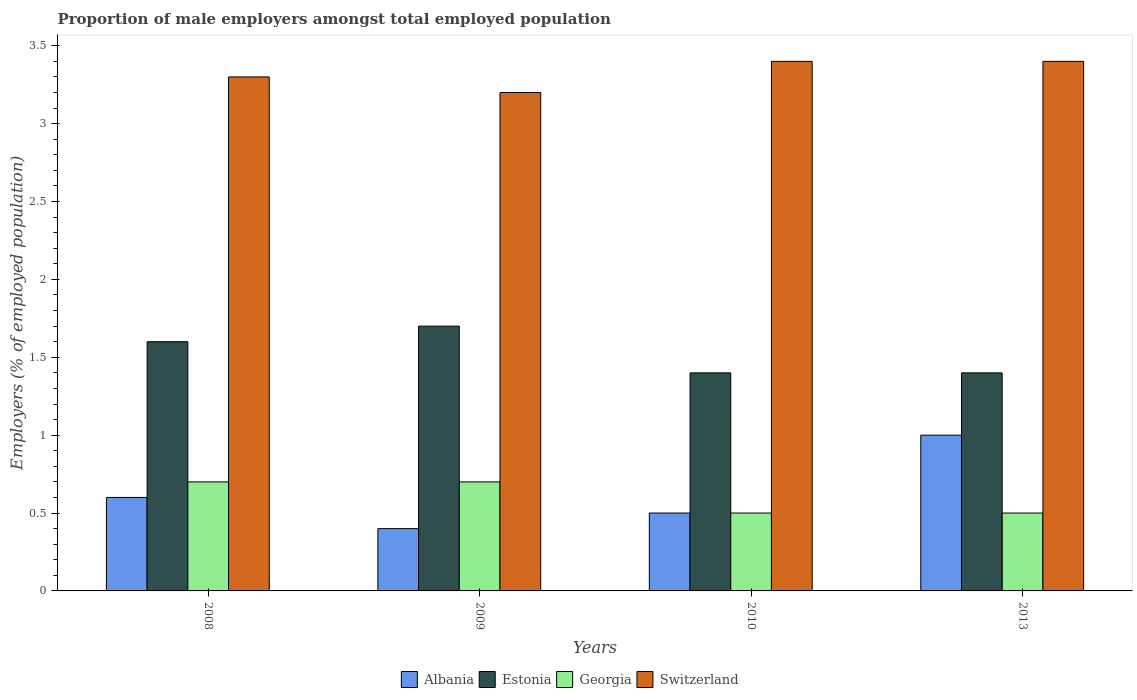How many groups of bars are there?
Provide a succinct answer. 4. Are the number of bars per tick equal to the number of legend labels?
Give a very brief answer. Yes. How many bars are there on the 2nd tick from the left?
Provide a succinct answer. 4. How many bars are there on the 1st tick from the right?
Your response must be concise. 4. What is the label of the 1st group of bars from the left?
Your answer should be very brief. 2008. In how many cases, is the number of bars for a given year not equal to the number of legend labels?
Provide a succinct answer. 0. What is the proportion of male employers in Albania in 2010?
Give a very brief answer. 0.5. Across all years, what is the maximum proportion of male employers in Estonia?
Give a very brief answer. 1.7. Across all years, what is the minimum proportion of male employers in Estonia?
Your response must be concise. 1.4. In which year was the proportion of male employers in Switzerland maximum?
Provide a succinct answer. 2010. What is the total proportion of male employers in Estonia in the graph?
Your answer should be compact. 6.1. What is the difference between the proportion of male employers in Estonia in 2009 and that in 2010?
Provide a succinct answer. 0.3. What is the difference between the proportion of male employers in Estonia in 2008 and the proportion of male employers in Switzerland in 2013?
Give a very brief answer. -1.8. What is the average proportion of male employers in Albania per year?
Provide a short and direct response. 0.63. In the year 2013, what is the difference between the proportion of male employers in Switzerland and proportion of male employers in Estonia?
Ensure brevity in your answer.  2. What is the ratio of the proportion of male employers in Estonia in 2009 to that in 2013?
Your answer should be very brief. 1.21. What is the difference between the highest and the second highest proportion of male employers in Albania?
Offer a very short reply. 0.4. What is the difference between the highest and the lowest proportion of male employers in Estonia?
Offer a very short reply. 0.3. Is it the case that in every year, the sum of the proportion of male employers in Estonia and proportion of male employers in Georgia is greater than the sum of proportion of male employers in Albania and proportion of male employers in Switzerland?
Offer a very short reply. No. What does the 2nd bar from the left in 2013 represents?
Make the answer very short. Estonia. What does the 2nd bar from the right in 2010 represents?
Ensure brevity in your answer.  Georgia. Is it the case that in every year, the sum of the proportion of male employers in Georgia and proportion of male employers in Switzerland is greater than the proportion of male employers in Estonia?
Provide a short and direct response. Yes. Are the values on the major ticks of Y-axis written in scientific E-notation?
Keep it short and to the point. No. Does the graph contain grids?
Make the answer very short. No. How are the legend labels stacked?
Keep it short and to the point. Horizontal. What is the title of the graph?
Ensure brevity in your answer.  Proportion of male employers amongst total employed population. Does "Montenegro" appear as one of the legend labels in the graph?
Your answer should be compact. No. What is the label or title of the X-axis?
Provide a succinct answer. Years. What is the label or title of the Y-axis?
Your answer should be very brief. Employers (% of employed population). What is the Employers (% of employed population) of Albania in 2008?
Provide a succinct answer. 0.6. What is the Employers (% of employed population) in Estonia in 2008?
Keep it short and to the point. 1.6. What is the Employers (% of employed population) of Georgia in 2008?
Offer a very short reply. 0.7. What is the Employers (% of employed population) in Switzerland in 2008?
Your answer should be compact. 3.3. What is the Employers (% of employed population) of Albania in 2009?
Provide a short and direct response. 0.4. What is the Employers (% of employed population) of Estonia in 2009?
Ensure brevity in your answer.  1.7. What is the Employers (% of employed population) in Georgia in 2009?
Keep it short and to the point. 0.7. What is the Employers (% of employed population) in Switzerland in 2009?
Your answer should be very brief. 3.2. What is the Employers (% of employed population) of Estonia in 2010?
Provide a succinct answer. 1.4. What is the Employers (% of employed population) in Georgia in 2010?
Ensure brevity in your answer.  0.5. What is the Employers (% of employed population) of Switzerland in 2010?
Your answer should be compact. 3.4. What is the Employers (% of employed population) in Albania in 2013?
Your response must be concise. 1. What is the Employers (% of employed population) in Estonia in 2013?
Offer a terse response. 1.4. What is the Employers (% of employed population) of Georgia in 2013?
Your response must be concise. 0.5. What is the Employers (% of employed population) of Switzerland in 2013?
Offer a terse response. 3.4. Across all years, what is the maximum Employers (% of employed population) of Estonia?
Provide a short and direct response. 1.7. Across all years, what is the maximum Employers (% of employed population) of Georgia?
Offer a very short reply. 0.7. Across all years, what is the maximum Employers (% of employed population) of Switzerland?
Make the answer very short. 3.4. Across all years, what is the minimum Employers (% of employed population) in Albania?
Provide a short and direct response. 0.4. Across all years, what is the minimum Employers (% of employed population) of Estonia?
Keep it short and to the point. 1.4. Across all years, what is the minimum Employers (% of employed population) of Switzerland?
Give a very brief answer. 3.2. What is the total Employers (% of employed population) of Georgia in the graph?
Offer a very short reply. 2.4. What is the difference between the Employers (% of employed population) in Estonia in 2008 and that in 2009?
Ensure brevity in your answer.  -0.1. What is the difference between the Employers (% of employed population) of Georgia in 2008 and that in 2009?
Ensure brevity in your answer.  0. What is the difference between the Employers (% of employed population) of Switzerland in 2008 and that in 2009?
Make the answer very short. 0.1. What is the difference between the Employers (% of employed population) in Albania in 2008 and that in 2010?
Offer a terse response. 0.1. What is the difference between the Employers (% of employed population) of Estonia in 2008 and that in 2010?
Provide a short and direct response. 0.2. What is the difference between the Employers (% of employed population) in Georgia in 2008 and that in 2010?
Ensure brevity in your answer.  0.2. What is the difference between the Employers (% of employed population) of Estonia in 2008 and that in 2013?
Provide a short and direct response. 0.2. What is the difference between the Employers (% of employed population) in Georgia in 2008 and that in 2013?
Provide a succinct answer. 0.2. What is the difference between the Employers (% of employed population) of Albania in 2009 and that in 2010?
Your response must be concise. -0.1. What is the difference between the Employers (% of employed population) in Estonia in 2009 and that in 2010?
Make the answer very short. 0.3. What is the difference between the Employers (% of employed population) of Georgia in 2009 and that in 2010?
Provide a succinct answer. 0.2. What is the difference between the Employers (% of employed population) in Albania in 2009 and that in 2013?
Ensure brevity in your answer.  -0.6. What is the difference between the Employers (% of employed population) of Estonia in 2009 and that in 2013?
Your answer should be compact. 0.3. What is the difference between the Employers (% of employed population) of Georgia in 2009 and that in 2013?
Ensure brevity in your answer.  0.2. What is the difference between the Employers (% of employed population) in Switzerland in 2009 and that in 2013?
Your answer should be compact. -0.2. What is the difference between the Employers (% of employed population) of Georgia in 2010 and that in 2013?
Offer a very short reply. 0. What is the difference between the Employers (% of employed population) of Switzerland in 2010 and that in 2013?
Ensure brevity in your answer.  0. What is the difference between the Employers (% of employed population) in Albania in 2008 and the Employers (% of employed population) in Georgia in 2009?
Provide a succinct answer. -0.1. What is the difference between the Employers (% of employed population) in Albania in 2008 and the Employers (% of employed population) in Switzerland in 2009?
Make the answer very short. -2.6. What is the difference between the Employers (% of employed population) of Georgia in 2008 and the Employers (% of employed population) of Switzerland in 2009?
Keep it short and to the point. -2.5. What is the difference between the Employers (% of employed population) of Albania in 2008 and the Employers (% of employed population) of Switzerland in 2010?
Offer a very short reply. -2.8. What is the difference between the Employers (% of employed population) of Estonia in 2008 and the Employers (% of employed population) of Georgia in 2010?
Give a very brief answer. 1.1. What is the difference between the Employers (% of employed population) of Albania in 2008 and the Employers (% of employed population) of Estonia in 2013?
Your answer should be very brief. -0.8. What is the difference between the Employers (% of employed population) of Albania in 2008 and the Employers (% of employed population) of Georgia in 2013?
Provide a succinct answer. 0.1. What is the difference between the Employers (% of employed population) in Albania in 2008 and the Employers (% of employed population) in Switzerland in 2013?
Make the answer very short. -2.8. What is the difference between the Employers (% of employed population) in Georgia in 2008 and the Employers (% of employed population) in Switzerland in 2013?
Provide a succinct answer. -2.7. What is the difference between the Employers (% of employed population) of Albania in 2009 and the Employers (% of employed population) of Georgia in 2010?
Offer a very short reply. -0.1. What is the difference between the Employers (% of employed population) in Albania in 2009 and the Employers (% of employed population) in Switzerland in 2010?
Your answer should be very brief. -3. What is the difference between the Employers (% of employed population) in Estonia in 2009 and the Employers (% of employed population) in Georgia in 2010?
Keep it short and to the point. 1.2. What is the difference between the Employers (% of employed population) of Estonia in 2009 and the Employers (% of employed population) of Switzerland in 2010?
Your answer should be compact. -1.7. What is the difference between the Employers (% of employed population) of Albania in 2009 and the Employers (% of employed population) of Estonia in 2013?
Offer a very short reply. -1. What is the difference between the Employers (% of employed population) in Albania in 2009 and the Employers (% of employed population) in Switzerland in 2013?
Make the answer very short. -3. What is the difference between the Employers (% of employed population) in Georgia in 2009 and the Employers (% of employed population) in Switzerland in 2013?
Make the answer very short. -2.7. What is the difference between the Employers (% of employed population) in Albania in 2010 and the Employers (% of employed population) in Estonia in 2013?
Your answer should be compact. -0.9. What is the difference between the Employers (% of employed population) in Albania in 2010 and the Employers (% of employed population) in Georgia in 2013?
Provide a succinct answer. 0. What is the difference between the Employers (% of employed population) of Albania in 2010 and the Employers (% of employed population) of Switzerland in 2013?
Give a very brief answer. -2.9. What is the difference between the Employers (% of employed population) in Estonia in 2010 and the Employers (% of employed population) in Georgia in 2013?
Give a very brief answer. 0.9. What is the average Employers (% of employed population) in Estonia per year?
Your answer should be compact. 1.52. What is the average Employers (% of employed population) of Georgia per year?
Offer a terse response. 0.6. What is the average Employers (% of employed population) in Switzerland per year?
Your answer should be very brief. 3.33. In the year 2008, what is the difference between the Employers (% of employed population) in Albania and Employers (% of employed population) in Estonia?
Your answer should be very brief. -1. In the year 2008, what is the difference between the Employers (% of employed population) in Albania and Employers (% of employed population) in Georgia?
Your answer should be very brief. -0.1. In the year 2008, what is the difference between the Employers (% of employed population) of Albania and Employers (% of employed population) of Switzerland?
Your answer should be very brief. -2.7. In the year 2008, what is the difference between the Employers (% of employed population) of Estonia and Employers (% of employed population) of Switzerland?
Provide a short and direct response. -1.7. In the year 2008, what is the difference between the Employers (% of employed population) in Georgia and Employers (% of employed population) in Switzerland?
Provide a short and direct response. -2.6. In the year 2009, what is the difference between the Employers (% of employed population) of Albania and Employers (% of employed population) of Georgia?
Provide a short and direct response. -0.3. In the year 2009, what is the difference between the Employers (% of employed population) in Estonia and Employers (% of employed population) in Georgia?
Make the answer very short. 1. In the year 2009, what is the difference between the Employers (% of employed population) in Georgia and Employers (% of employed population) in Switzerland?
Keep it short and to the point. -2.5. In the year 2010, what is the difference between the Employers (% of employed population) in Albania and Employers (% of employed population) in Estonia?
Provide a short and direct response. -0.9. In the year 2010, what is the difference between the Employers (% of employed population) in Albania and Employers (% of employed population) in Georgia?
Keep it short and to the point. 0. In the year 2010, what is the difference between the Employers (% of employed population) in Estonia and Employers (% of employed population) in Georgia?
Keep it short and to the point. 0.9. In the year 2013, what is the difference between the Employers (% of employed population) of Albania and Employers (% of employed population) of Estonia?
Provide a short and direct response. -0.4. In the year 2013, what is the difference between the Employers (% of employed population) of Estonia and Employers (% of employed population) of Georgia?
Offer a terse response. 0.9. What is the ratio of the Employers (% of employed population) in Estonia in 2008 to that in 2009?
Offer a very short reply. 0.94. What is the ratio of the Employers (% of employed population) in Switzerland in 2008 to that in 2009?
Keep it short and to the point. 1.03. What is the ratio of the Employers (% of employed population) in Albania in 2008 to that in 2010?
Your answer should be very brief. 1.2. What is the ratio of the Employers (% of employed population) of Estonia in 2008 to that in 2010?
Give a very brief answer. 1.14. What is the ratio of the Employers (% of employed population) in Georgia in 2008 to that in 2010?
Keep it short and to the point. 1.4. What is the ratio of the Employers (% of employed population) in Switzerland in 2008 to that in 2010?
Offer a very short reply. 0.97. What is the ratio of the Employers (% of employed population) in Albania in 2008 to that in 2013?
Offer a terse response. 0.6. What is the ratio of the Employers (% of employed population) of Estonia in 2008 to that in 2013?
Provide a short and direct response. 1.14. What is the ratio of the Employers (% of employed population) in Georgia in 2008 to that in 2013?
Your response must be concise. 1.4. What is the ratio of the Employers (% of employed population) of Switzerland in 2008 to that in 2013?
Provide a short and direct response. 0.97. What is the ratio of the Employers (% of employed population) in Albania in 2009 to that in 2010?
Give a very brief answer. 0.8. What is the ratio of the Employers (% of employed population) in Estonia in 2009 to that in 2010?
Your response must be concise. 1.21. What is the ratio of the Employers (% of employed population) in Albania in 2009 to that in 2013?
Provide a short and direct response. 0.4. What is the ratio of the Employers (% of employed population) of Estonia in 2009 to that in 2013?
Provide a short and direct response. 1.21. What is the ratio of the Employers (% of employed population) of Estonia in 2010 to that in 2013?
Your answer should be compact. 1. What is the ratio of the Employers (% of employed population) in Switzerland in 2010 to that in 2013?
Provide a short and direct response. 1. What is the difference between the highest and the second highest Employers (% of employed population) of Georgia?
Your response must be concise. 0. What is the difference between the highest and the lowest Employers (% of employed population) of Albania?
Provide a short and direct response. 0.6. What is the difference between the highest and the lowest Employers (% of employed population) of Estonia?
Give a very brief answer. 0.3. What is the difference between the highest and the lowest Employers (% of employed population) in Georgia?
Offer a terse response. 0.2. 